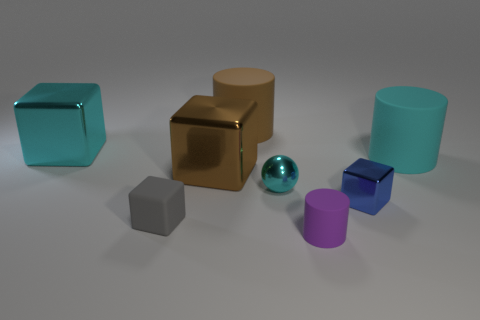Is the number of purple cylinders greater than the number of small brown rubber objects?
Your answer should be very brief. Yes. Is there anything else that has the same color as the metal ball?
Make the answer very short. Yes. Are the sphere and the brown block made of the same material?
Your answer should be compact. Yes. Is the number of big brown cubes less than the number of cyan shiny cylinders?
Provide a succinct answer. No. Do the tiny gray thing and the brown matte object have the same shape?
Your answer should be very brief. No. What color is the rubber cube?
Ensure brevity in your answer.  Gray. How many other things are there of the same material as the tiny cyan sphere?
Keep it short and to the point. 3. How many gray objects are big things or small rubber cylinders?
Make the answer very short. 0. Is the shape of the brown thing that is left of the big brown rubber thing the same as the large matte object that is right of the small shiny sphere?
Offer a very short reply. No. Does the ball have the same color as the large cylinder to the right of the brown rubber cylinder?
Give a very brief answer. Yes. 